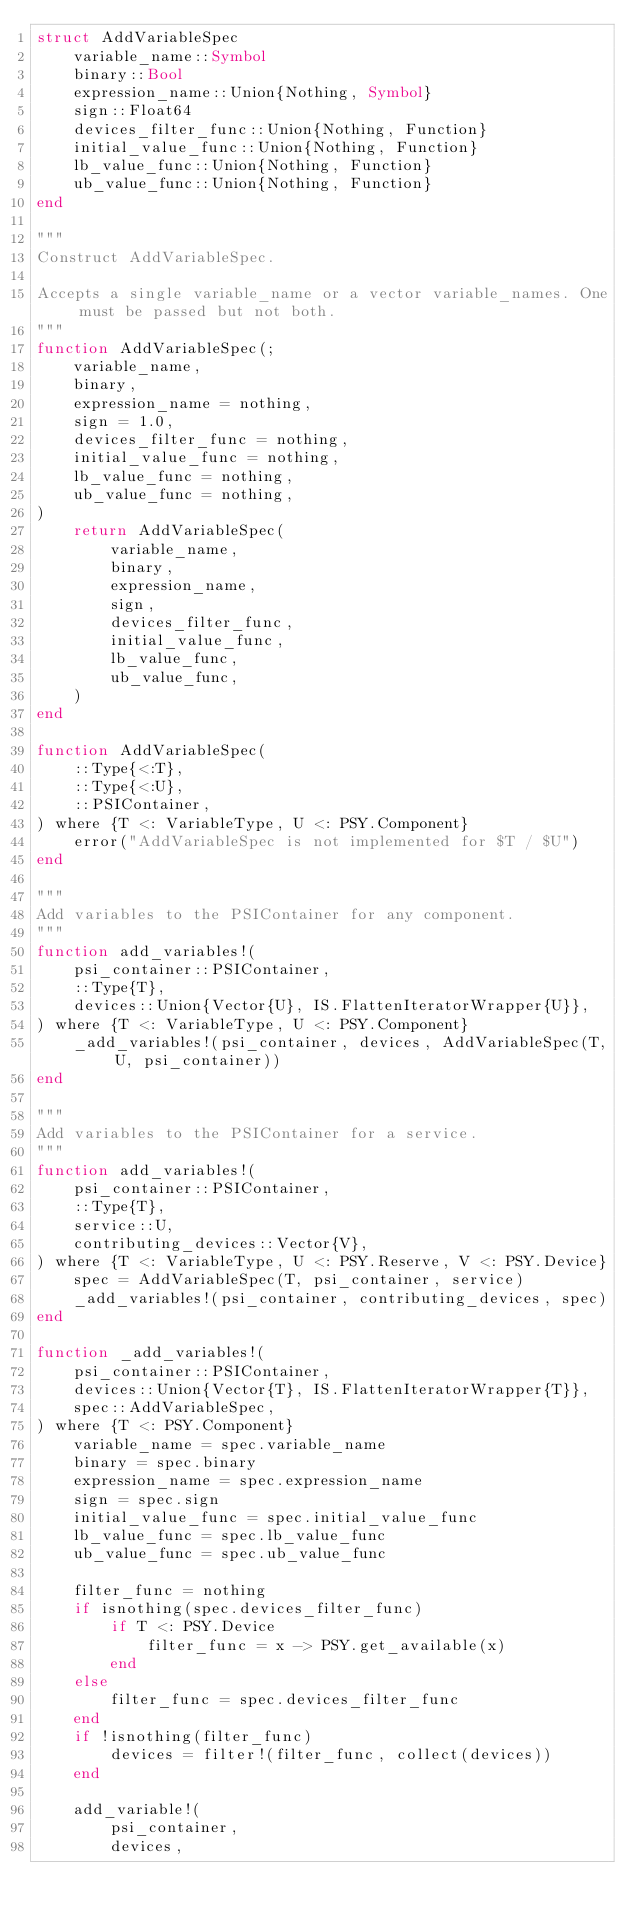Convert code to text. <code><loc_0><loc_0><loc_500><loc_500><_Julia_>struct AddVariableSpec
    variable_name::Symbol
    binary::Bool
    expression_name::Union{Nothing, Symbol}
    sign::Float64
    devices_filter_func::Union{Nothing, Function}
    initial_value_func::Union{Nothing, Function}
    lb_value_func::Union{Nothing, Function}
    ub_value_func::Union{Nothing, Function}
end

"""
Construct AddVariableSpec.

Accepts a single variable_name or a vector variable_names. One must be passed but not both.
"""
function AddVariableSpec(;
    variable_name,
    binary,
    expression_name = nothing,
    sign = 1.0,
    devices_filter_func = nothing,
    initial_value_func = nothing,
    lb_value_func = nothing,
    ub_value_func = nothing,
)
    return AddVariableSpec(
        variable_name,
        binary,
        expression_name,
        sign,
        devices_filter_func,
        initial_value_func,
        lb_value_func,
        ub_value_func,
    )
end

function AddVariableSpec(
    ::Type{<:T},
    ::Type{<:U},
    ::PSIContainer,
) where {T <: VariableType, U <: PSY.Component}
    error("AddVariableSpec is not implemented for $T / $U")
end

"""
Add variables to the PSIContainer for any component.
"""
function add_variables!(
    psi_container::PSIContainer,
    ::Type{T},
    devices::Union{Vector{U}, IS.FlattenIteratorWrapper{U}},
) where {T <: VariableType, U <: PSY.Component}
    _add_variables!(psi_container, devices, AddVariableSpec(T, U, psi_container))
end

"""
Add variables to the PSIContainer for a service.
"""
function add_variables!(
    psi_container::PSIContainer,
    ::Type{T},
    service::U,
    contributing_devices::Vector{V},
) where {T <: VariableType, U <: PSY.Reserve, V <: PSY.Device}
    spec = AddVariableSpec(T, psi_container, service)
    _add_variables!(psi_container, contributing_devices, spec)
end

function _add_variables!(
    psi_container::PSIContainer,
    devices::Union{Vector{T}, IS.FlattenIteratorWrapper{T}},
    spec::AddVariableSpec,
) where {T <: PSY.Component}
    variable_name = spec.variable_name
    binary = spec.binary
    expression_name = spec.expression_name
    sign = spec.sign
    initial_value_func = spec.initial_value_func
    lb_value_func = spec.lb_value_func
    ub_value_func = spec.ub_value_func

    filter_func = nothing
    if isnothing(spec.devices_filter_func)
        if T <: PSY.Device
            filter_func = x -> PSY.get_available(x)
        end
    else
        filter_func = spec.devices_filter_func
    end
    if !isnothing(filter_func)
        devices = filter!(filter_func, collect(devices))
    end

    add_variable!(
        psi_container,
        devices,</code> 